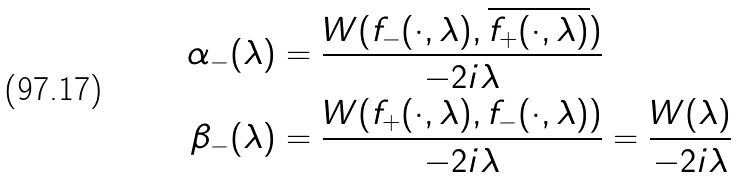Convert formula to latex. <formula><loc_0><loc_0><loc_500><loc_500>\alpha _ { - } ( \lambda ) & = \frac { W ( f _ { - } ( \cdot , \lambda ) , \overline { f _ { + } ( \cdot , \lambda ) } ) } { - 2 i \lambda } \\ \beta _ { - } ( \lambda ) & = \frac { W ( f _ { + } ( \cdot , \lambda ) , f _ { - } ( \cdot , \lambda ) ) } { - 2 i \lambda } = \frac { W ( \lambda ) } { - 2 i \lambda }</formula> 